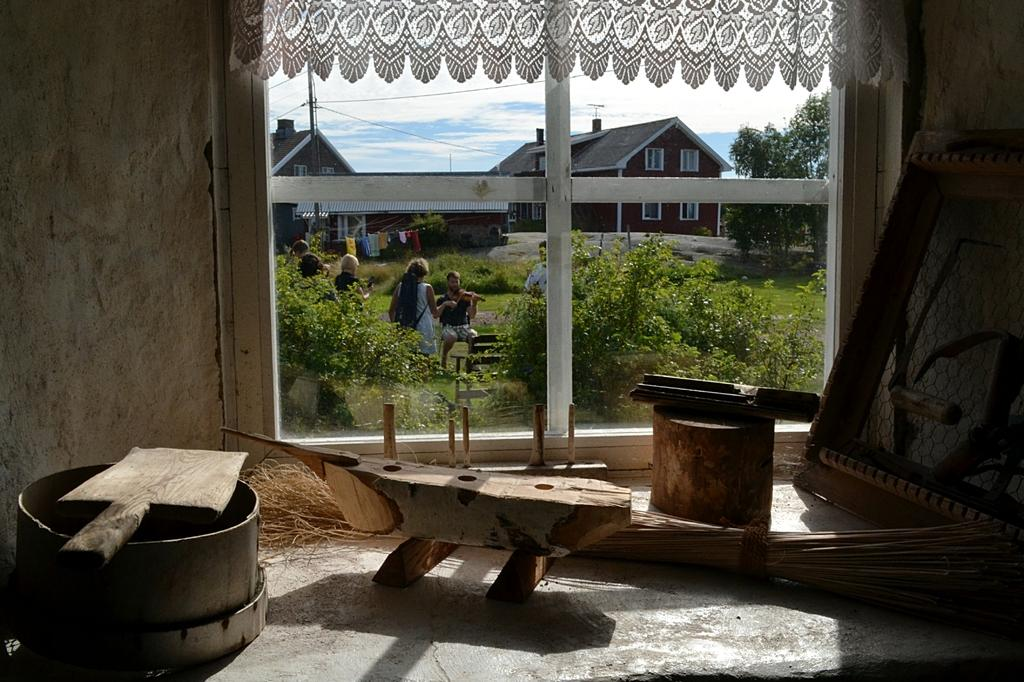What type of objects can be seen at the bottom of the image? There are wooden objects at the bottom side of the image. What is located in the center of the image? There is a window in the center of the image. What can be seen outside the window? Houses, trees, and people are visible outside the window. What type of quiver is visible outside the window? There is no quiver present in the image; only houses, trees, and people are visible outside the window. Can you describe the veins of the trees outside the window? There is no mention of the trees' veins in the image, as the focus is on their presence and not their internal structure. 